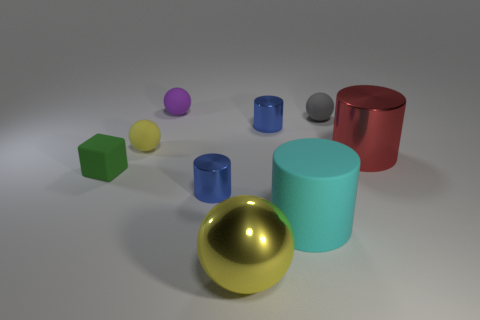How many blue cylinders must be subtracted to get 1 blue cylinders? 1 Subtract 1 spheres. How many spheres are left? 3 Add 1 metallic things. How many objects exist? 10 Subtract all cylinders. How many objects are left? 5 Add 2 cylinders. How many cylinders are left? 6 Add 4 small spheres. How many small spheres exist? 7 Subtract 1 green blocks. How many objects are left? 8 Subtract all small yellow rubber spheres. Subtract all tiny purple balls. How many objects are left? 7 